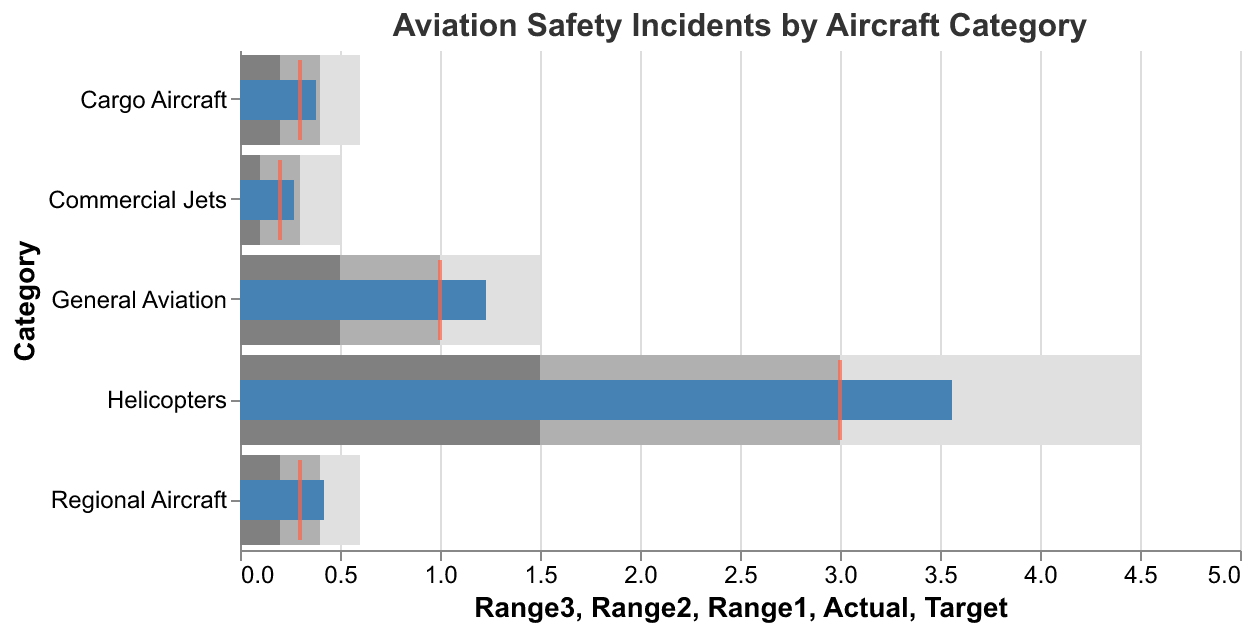What is the target value for General Aviation incidents? The target value for General Aviation incidents can be found by looking at the tick mark positioned within the General Aviation category bar, which is placed at 1.0.
Answer: 1.0 Which category has the highest actual incident rate? By comparing the actual incident bars across categories, the Helicopters category has the highest bar, which indicates that it has the highest actual incident rate of 3.56.
Answer: Helicopters What is the color of the bars representing the 'Range1' values? The bars representing the 'Range1' values are in a visible shade of gray, specifically "#808080". This can be distinguished among the other colors in the figure.
Answer: Gray How do the actual incident rates of Commercial Jets compare to their target value? For Commercial Jets, the actual incident rate is represented by a filled blue bar reaching 0.27. The target value is marked by a tick at 0.2. Since 0.27 is higher than 0.2, the actual rate exceeds the target.
Answer: 0.27 is higher than 0.2 What is the median range (Range2) for Helicopters? The values of the ranges for Helicopters are provided in the data: Range1, Range2, and Range3 are 1.5, 3.0, and 4.5 respectively. The median range (Range2) can be verified by locating the middle gray band at 3.0.
Answer: 3.0 Which categories have incident rates below their targets? Comparing the actual values and targets, no category has incidents rates below their targets.
Answer: None What are the boundaries of the 'Range3' for Regional Aircraft? By analyzing the positions of the 'Range3' bar for the Regional Aircraft category in context with the x-axis scale, Range3 ranges from 0 to 0.6, with 0.6 being its upper boundary.
Answer: 0 to 0.6 What is the difference between the actual and target values for Cargo Aircraft? The actual value for Cargo Aircraft is 0.38 and its target is 0.3. The difference can be calculated by subtracting the target from the actual: 0.38 - 0.3 = 0.08.
Answer: 0.08 What category has the closest actual incidents to the target value? By examining the bars and ticks for each category, Commercial Jets show an actual value very close to its target (0.27 actual vs 0.2 target), making it the closest match among the given categories.
Answer: Commercial Jets 